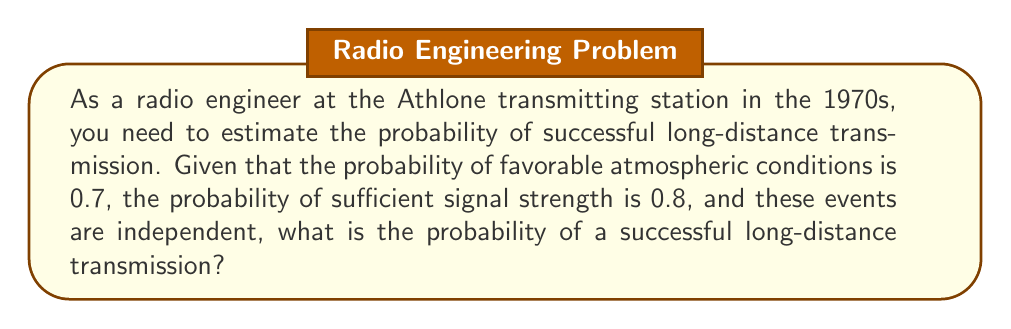Can you solve this math problem? To solve this problem, we need to follow these steps:

1. Identify the events:
   Let A = favorable atmospheric conditions
   Let B = sufficient signal strength

2. Given probabilities:
   P(A) = 0.7
   P(B) = 0.8

3. The events are independent, so we can use the multiplication rule of probability:
   P(A and B) = P(A) × P(B)

4. Calculate the probability of successful transmission:
   P(successful transmission) = P(A and B)
   $$ P(\text{successful transmission}) = P(A) \times P(B) $$
   $$ P(\text{successful transmission}) = 0.7 \times 0.8 $$
   $$ P(\text{successful transmission}) = 0.56 $$

5. Convert to percentage:
   0.56 × 100% = 56%

Therefore, the probability of a successful long-distance transmission under these conditions is 0.56 or 56%.
Answer: 0.56 